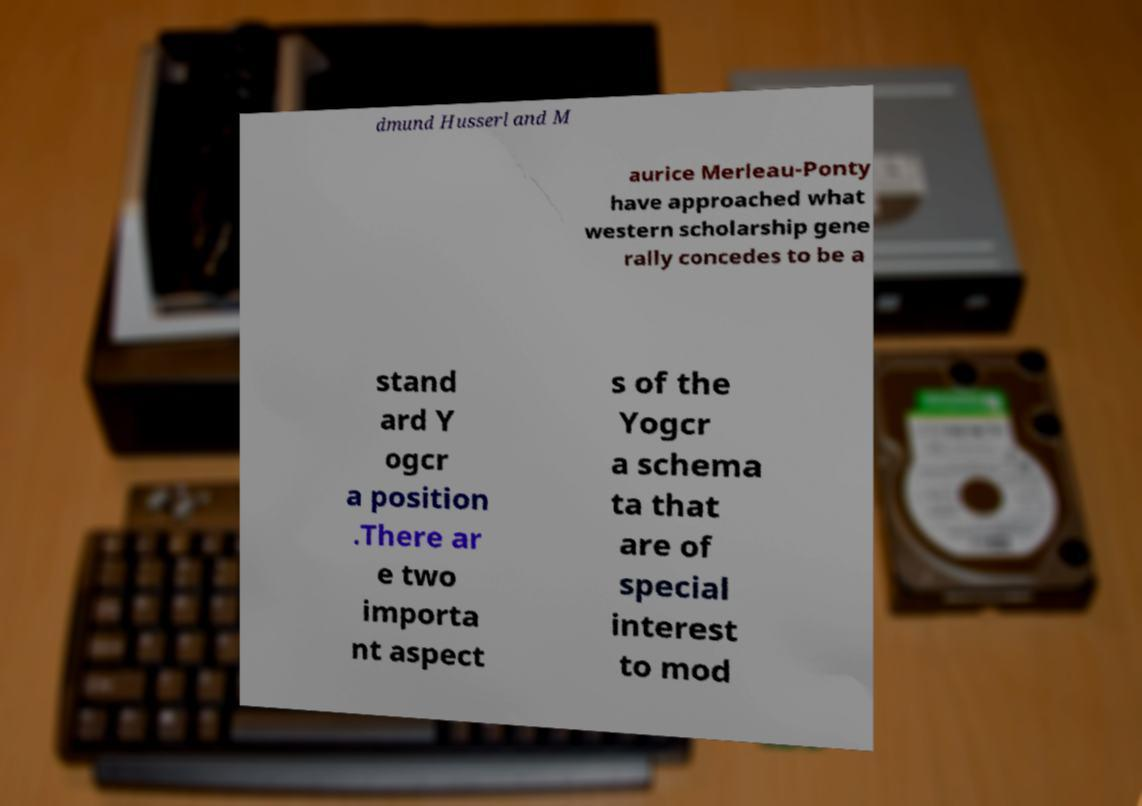I need the written content from this picture converted into text. Can you do that? dmund Husserl and M aurice Merleau-Ponty have approached what western scholarship gene rally concedes to be a stand ard Y ogcr a position .There ar e two importa nt aspect s of the Yogcr a schema ta that are of special interest to mod 